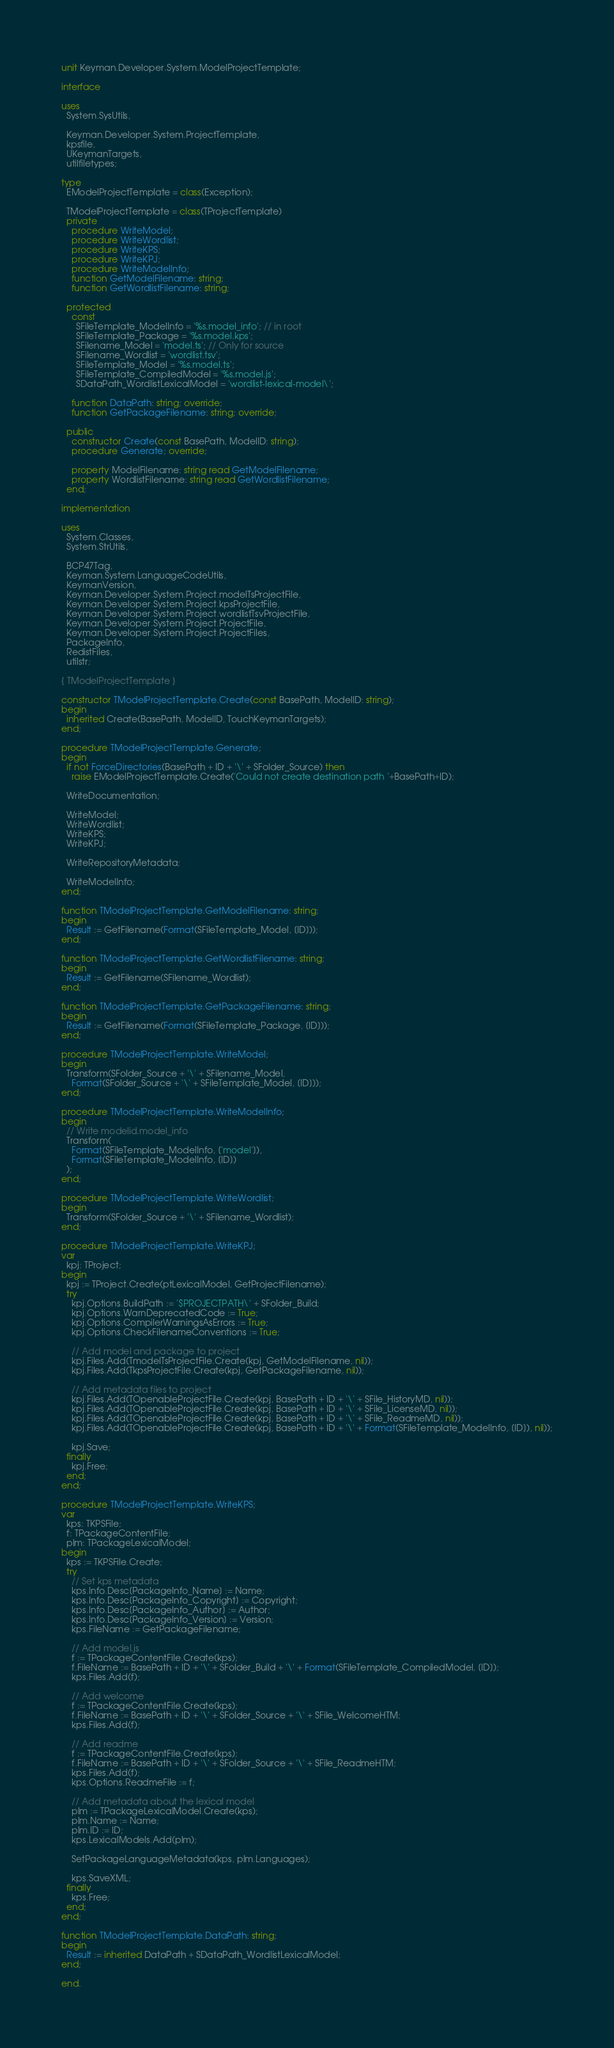<code> <loc_0><loc_0><loc_500><loc_500><_Pascal_>unit Keyman.Developer.System.ModelProjectTemplate;

interface

uses
  System.SysUtils,

  Keyman.Developer.System.ProjectTemplate,
  kpsfile,
  UKeymanTargets,
  utilfiletypes;

type
  EModelProjectTemplate = class(Exception);

  TModelProjectTemplate = class(TProjectTemplate)
  private
    procedure WriteModel;
    procedure WriteWordlist;
    procedure WriteKPS;
    procedure WriteKPJ;
    procedure WriteModelInfo;
    function GetModelFilename: string;
    function GetWordlistFilename: string;

  protected
    const
      SFileTemplate_ModelInfo = '%s.model_info'; // in root
      SFileTemplate_Package = '%s.model.kps';
      SFilename_Model = 'model.ts'; // Only for source
      SFilename_Wordlist = 'wordlist.tsv';
      SFileTemplate_Model = '%s.model.ts';
      SFileTemplate_CompiledModel = '%s.model.js';
      SDataPath_WordlistLexicalModel = 'wordlist-lexical-model\';

    function DataPath: string; override;
    function GetPackageFilename: string; override;

  public
    constructor Create(const BasePath, ModelID: string);
    procedure Generate; override;

    property ModelFilename: string read GetModelFilename;
    property WordlistFilename: string read GetWordlistFilename;
  end;

implementation

uses
  System.Classes,
  System.StrUtils,

  BCP47Tag,
  Keyman.System.LanguageCodeUtils,
  KeymanVersion,
  Keyman.Developer.System.Project.modelTsProjectFile,
  Keyman.Developer.System.Project.kpsProjectFile,
  Keyman.Developer.System.Project.wordlistTsvProjectFile,
  Keyman.Developer.System.Project.ProjectFile,
  Keyman.Developer.System.Project.ProjectFiles,
  PackageInfo,
  RedistFiles,
  utilstr;

{ TModelProjectTemplate }

constructor TModelProjectTemplate.Create(const BasePath, ModelID: string);
begin
  inherited Create(BasePath, ModelID, TouchKeymanTargets);
end;

procedure TModelProjectTemplate.Generate;
begin
  if not ForceDirectories(BasePath + ID + '\' + SFolder_Source) then
    raise EModelProjectTemplate.Create('Could not create destination path '+BasePath+ID);

  WriteDocumentation;

  WriteModel;
  WriteWordlist;
  WriteKPS;
  WriteKPJ;

  WriteRepositoryMetadata;

  WriteModelInfo;
end;

function TModelProjectTemplate.GetModelFilename: string;
begin
  Result := GetFilename(Format(SFileTemplate_Model, [ID]));
end;

function TModelProjectTemplate.GetWordlistFilename: string;
begin
  Result := GetFilename(SFilename_Wordlist);
end;

function TModelProjectTemplate.GetPackageFilename: string;
begin
  Result := GetFilename(Format(SFileTemplate_Package, [ID]));
end;

procedure TModelProjectTemplate.WriteModel;
begin
  Transform(SFolder_Source + '\' + SFilename_Model,
    Format(SFolder_Source + '\' + SFileTemplate_Model, [ID]));
end;

procedure TModelProjectTemplate.WriteModelInfo;
begin
  // Write modelid.model_info
  Transform(
    Format(SFileTemplate_ModelInfo, ['model']),
    Format(SFileTemplate_ModelInfo, [ID])
  );
end;

procedure TModelProjectTemplate.WriteWordlist;
begin
  Transform(SFolder_Source + '\' + SFilename_Wordlist);
end;

procedure TModelProjectTemplate.WriteKPJ;
var
  kpj: TProject;
begin
  kpj := TProject.Create(ptLexicalModel, GetProjectFilename);
  try
    kpj.Options.BuildPath := '$PROJECTPATH\' + SFolder_Build;
    kpj.Options.WarnDeprecatedCode := True;
    kpj.Options.CompilerWarningsAsErrors := True;
    kpj.Options.CheckFilenameConventions := True;

    // Add model and package to project
    kpj.Files.Add(TmodelTsProjectFile.Create(kpj, GetModelFilename, nil));
    kpj.Files.Add(TkpsProjectFile.Create(kpj, GetPackageFilename, nil));

    // Add metadata files to project
    kpj.Files.Add(TOpenableProjectFile.Create(kpj, BasePath + ID + '\' + SFile_HistoryMD, nil));
    kpj.Files.Add(TOpenableProjectFile.Create(kpj, BasePath + ID + '\' + SFile_LicenseMD, nil));
    kpj.Files.Add(TOpenableProjectFile.Create(kpj, BasePath + ID + '\' + SFile_ReadmeMD, nil));
    kpj.Files.Add(TOpenableProjectFile.Create(kpj, BasePath + ID + '\' + Format(SFileTemplate_ModelInfo, [ID]), nil));

    kpj.Save;
  finally
    kpj.Free;
  end;
end;

procedure TModelProjectTemplate.WriteKPS;
var
  kps: TKPSFile;
  f: TPackageContentFile;
  plm: TPackageLexicalModel;
begin
  kps := TKPSFile.Create;
  try
    // Set kps metadata
    kps.Info.Desc[PackageInfo_Name] := Name;
    kps.Info.Desc[PackageInfo_Copyright] := Copyright;
    kps.Info.Desc[PackageInfo_Author] := Author;
    kps.Info.Desc[PackageInfo_Version] := Version;
    kps.FileName := GetPackageFilename;

    // Add model.js
    f := TPackageContentFile.Create(kps);
    f.FileName := BasePath + ID + '\' + SFolder_Build + '\' + Format(SFileTemplate_CompiledModel, [ID]);
    kps.Files.Add(f);

    // Add welcome
    f := TPackageContentFile.Create(kps);
    f.FileName := BasePath + ID + '\' + SFolder_Source + '\' + SFile_WelcomeHTM;
    kps.Files.Add(f);

    // Add readme
    f := TPackageContentFile.Create(kps);
    f.FileName := BasePath + ID + '\' + SFolder_Source + '\' + SFile_ReadmeHTM;
    kps.Files.Add(f);
    kps.Options.ReadmeFile := f;

    // Add metadata about the lexical model
    plm := TPackageLexicalModel.Create(kps);
    plm.Name := Name;
    plm.ID := ID;
    kps.LexicalModels.Add(plm);

    SetPackageLanguageMetadata(kps, plm.Languages);

    kps.SaveXML;
  finally
    kps.Free;
  end;
end;

function TModelProjectTemplate.DataPath: string;
begin
  Result := inherited DataPath + SDataPath_WordlistLexicalModel;
end;

end.
</code> 